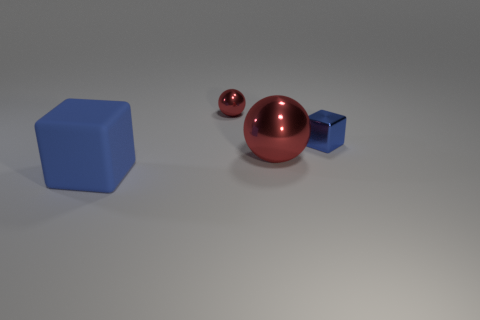Subtract all red balls. How many were subtracted if there are1red balls left? 1 Add 3 red shiny spheres. How many objects exist? 7 Subtract 1 balls. How many balls are left? 1 Add 4 big blue matte blocks. How many big blue matte blocks are left? 5 Add 1 red balls. How many red balls exist? 3 Subtract 0 purple blocks. How many objects are left? 4 Subtract all yellow spheres. Subtract all purple cubes. How many spheres are left? 2 Subtract all large brown metallic things. Subtract all metal cubes. How many objects are left? 3 